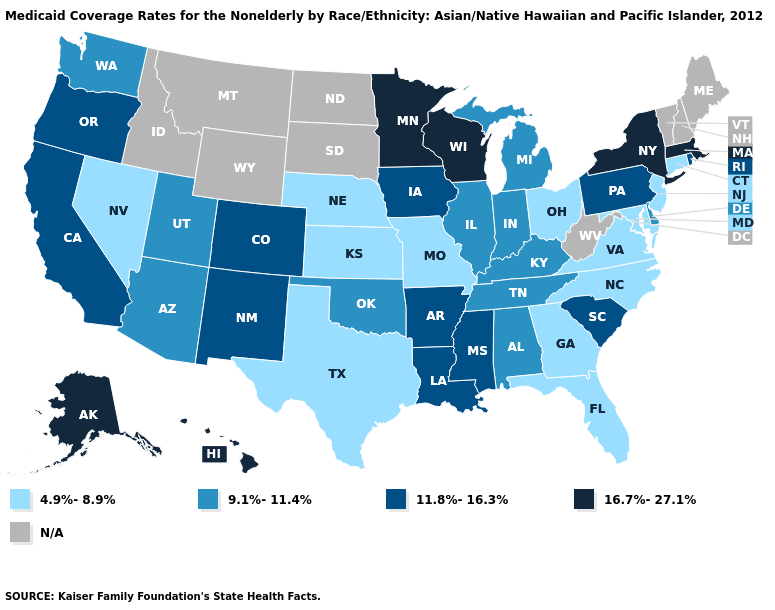What is the lowest value in the South?
Answer briefly. 4.9%-8.9%. What is the value of Virginia?
Short answer required. 4.9%-8.9%. Does Missouri have the lowest value in the USA?
Short answer required. Yes. Does New York have the highest value in the USA?
Keep it brief. Yes. Among the states that border Texas , does New Mexico have the lowest value?
Answer briefly. No. Name the states that have a value in the range 9.1%-11.4%?
Concise answer only. Alabama, Arizona, Delaware, Illinois, Indiana, Kentucky, Michigan, Oklahoma, Tennessee, Utah, Washington. Does Connecticut have the highest value in the USA?
Write a very short answer. No. What is the lowest value in the USA?
Keep it brief. 4.9%-8.9%. Which states have the lowest value in the USA?
Be succinct. Connecticut, Florida, Georgia, Kansas, Maryland, Missouri, Nebraska, Nevada, New Jersey, North Carolina, Ohio, Texas, Virginia. What is the highest value in the USA?
Answer briefly. 16.7%-27.1%. Which states hav the highest value in the MidWest?
Give a very brief answer. Minnesota, Wisconsin. Does Louisiana have the highest value in the USA?
Be succinct. No. 